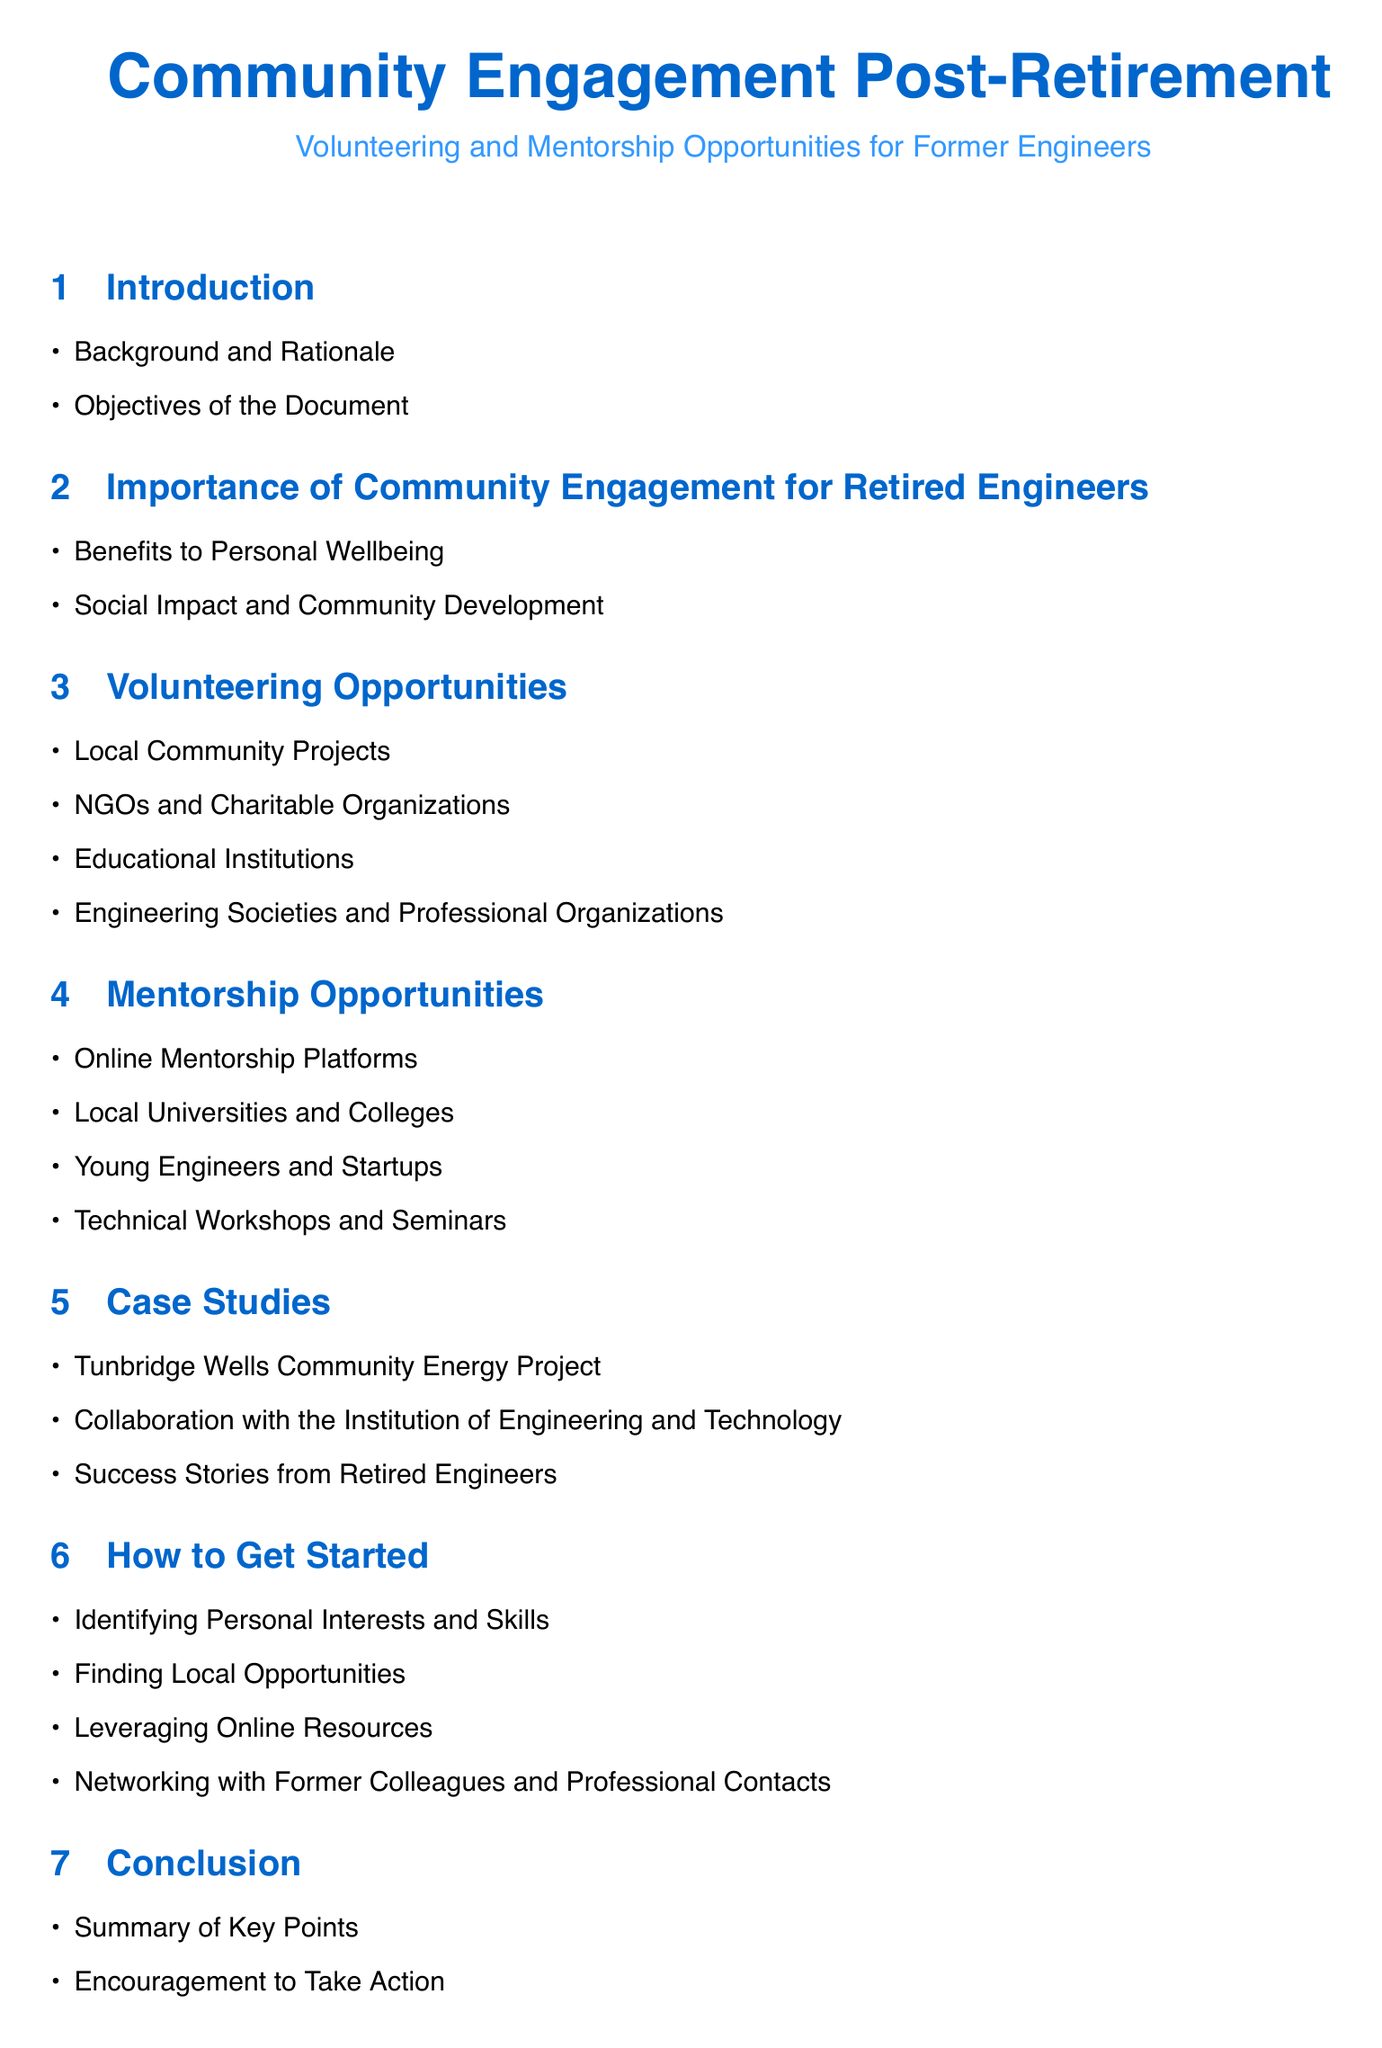What is the main title of the document? The main title provides information about the focus of the document, which is community engagement for retired engineers.
Answer: Community Engagement Post-Retirement How many sections are in the document? The count of sections is derived from the main structure outlined in the table of contents.
Answer: 7 What is one type of organization mentioned for volunteering opportunities? This refers to one of the specific examples listed within the "Volunteering Opportunities" section.
Answer: NGOs and Charitable Organizations What is one reason for community engagement mentioned in the document? The question targets the benefits outlined in the "Importance of Community Engagement" section.
Answer: Benefits to Personal Wellbeing Which project is listed as a case study? This asks for a specific example of a community project related to energy in the case studies section.
Answer: Tunbridge Wells Community Energy Project What is a suggested step to get started with community engagement? This seeks to identify an action or strategy listed in the "How to Get Started" section.
Answer: Identifying Personal Interests and Skills What does the document encourage in its conclusion? The conclusion summarizes the overall message of the document, asking for a call to action.
Answer: Encouragement to Take Action Which section discusses the benefits of community development? This looks for a specific section that outlines the social implications of engagement.
Answer: Importance of Community Engagement for Retired Engineers 